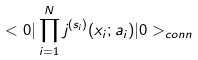Convert formula to latex. <formula><loc_0><loc_0><loc_500><loc_500>< 0 | \prod _ { i = 1 } ^ { N } j ^ { ( s _ { i } ) } ( x _ { i } ; a _ { i } ) | 0 > _ { c o n n }</formula> 